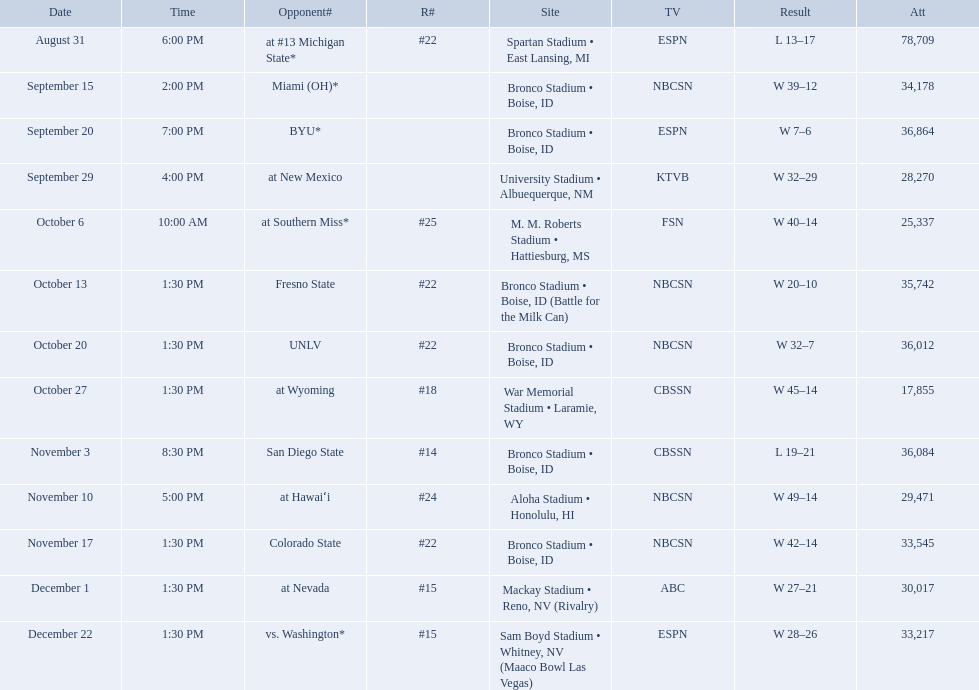Who were all of the opponents? At #13 michigan state*, miami (oh)*, byu*, at new mexico, at southern miss*, fresno state, unlv, at wyoming, san diego state, at hawaiʻi, colorado state, at nevada, vs. washington*. Who did they face on november 3rd? San Diego State. What rank were they on november 3rd? #14. 